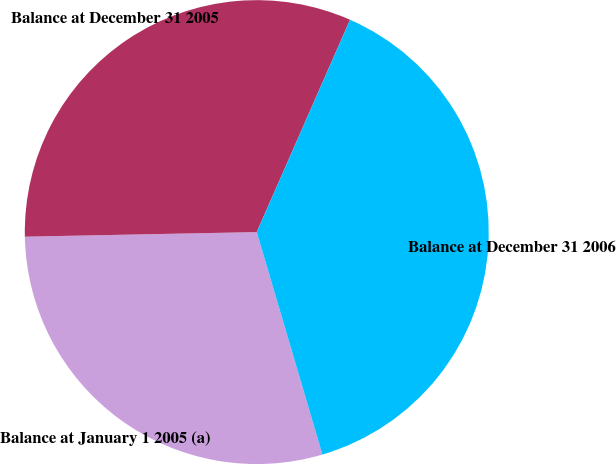Convert chart to OTSL. <chart><loc_0><loc_0><loc_500><loc_500><pie_chart><fcel>Balance at January 1 2005 (a)<fcel>Balance at December 31 2005<fcel>Balance at December 31 2006<nl><fcel>29.25%<fcel>31.9%<fcel>38.84%<nl></chart> 